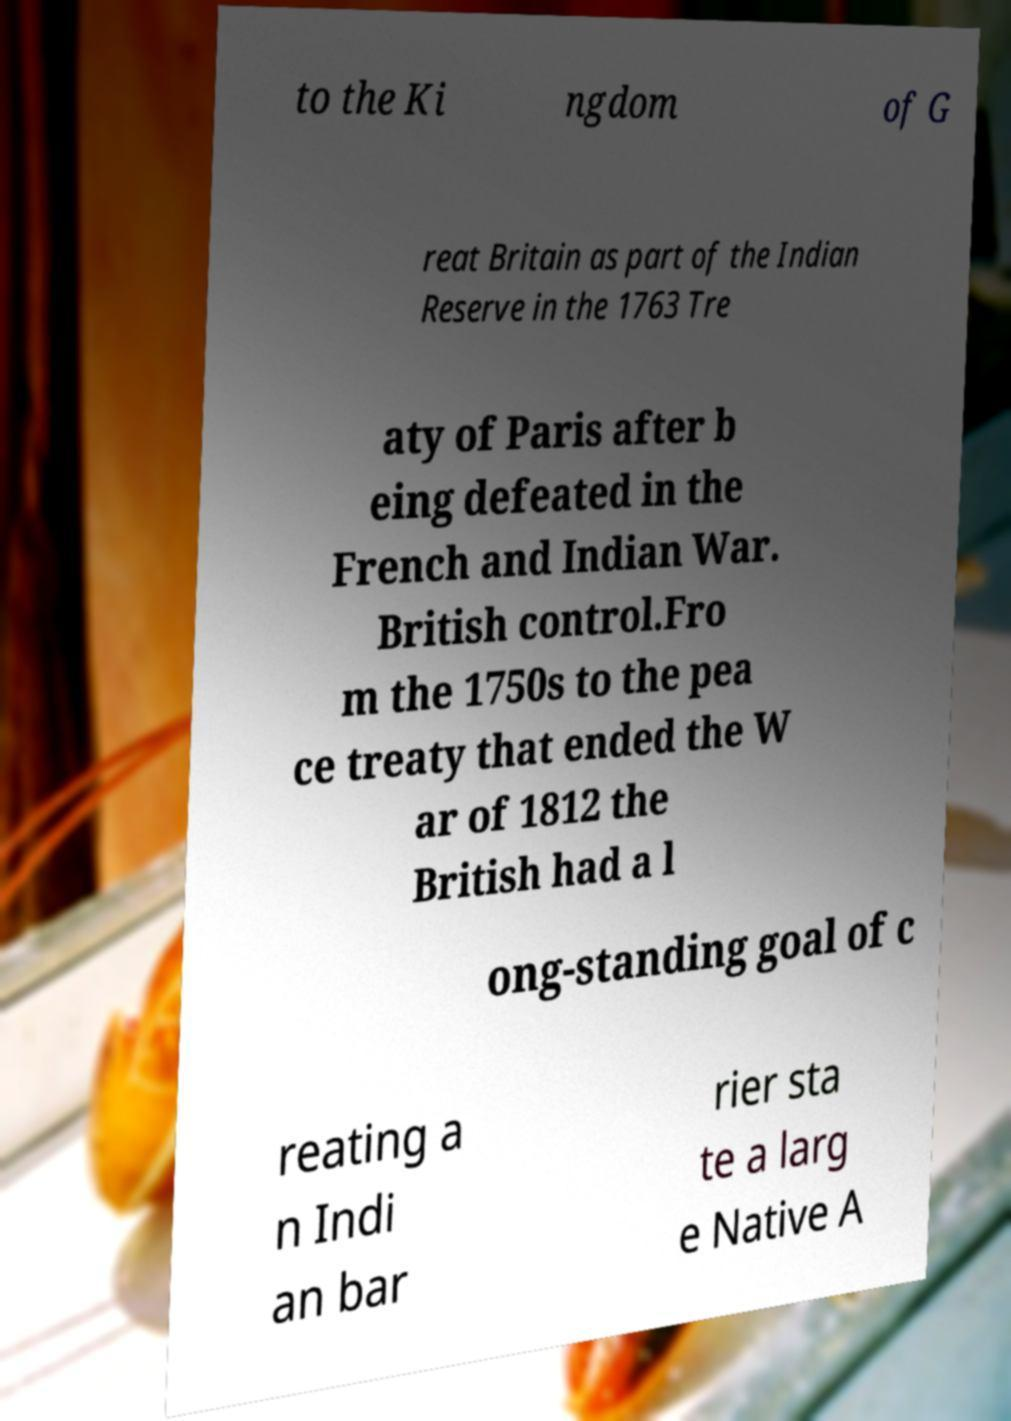Can you accurately transcribe the text from the provided image for me? to the Ki ngdom of G reat Britain as part of the Indian Reserve in the 1763 Tre aty of Paris after b eing defeated in the French and Indian War. British control.Fro m the 1750s to the pea ce treaty that ended the W ar of 1812 the British had a l ong-standing goal of c reating a n Indi an bar rier sta te a larg e Native A 